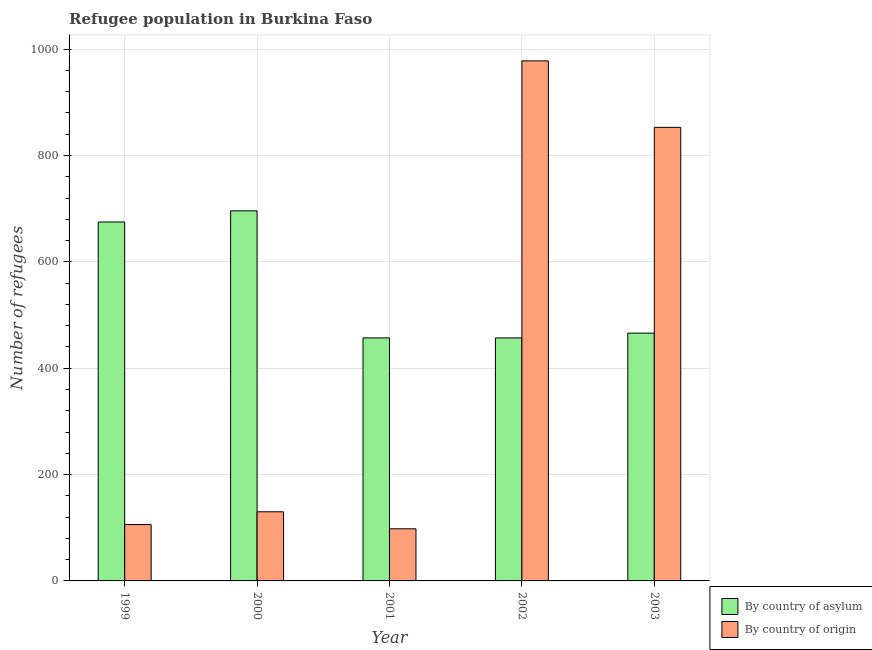How many different coloured bars are there?
Provide a short and direct response. 2. Are the number of bars per tick equal to the number of legend labels?
Offer a very short reply. Yes. How many bars are there on the 5th tick from the right?
Give a very brief answer. 2. What is the number of refugees by country of origin in 2000?
Give a very brief answer. 130. Across all years, what is the maximum number of refugees by country of asylum?
Offer a very short reply. 696. Across all years, what is the minimum number of refugees by country of asylum?
Provide a short and direct response. 457. In which year was the number of refugees by country of origin maximum?
Ensure brevity in your answer.  2002. What is the total number of refugees by country of asylum in the graph?
Your answer should be compact. 2751. What is the difference between the number of refugees by country of asylum in 2000 and that in 2002?
Your answer should be very brief. 239. What is the difference between the number of refugees by country of asylum in 2001 and the number of refugees by country of origin in 2003?
Ensure brevity in your answer.  -9. What is the average number of refugees by country of origin per year?
Your answer should be compact. 433. What is the ratio of the number of refugees by country of origin in 2002 to that in 2003?
Give a very brief answer. 1.15. Is the number of refugees by country of asylum in 2000 less than that in 2002?
Your response must be concise. No. What is the difference between the highest and the second highest number of refugees by country of origin?
Make the answer very short. 125. What is the difference between the highest and the lowest number of refugees by country of asylum?
Keep it short and to the point. 239. What does the 1st bar from the left in 2000 represents?
Your answer should be very brief. By country of asylum. What does the 2nd bar from the right in 2002 represents?
Provide a short and direct response. By country of asylum. How many bars are there?
Offer a very short reply. 10. What is the difference between two consecutive major ticks on the Y-axis?
Your answer should be compact. 200. Does the graph contain any zero values?
Ensure brevity in your answer.  No. Where does the legend appear in the graph?
Offer a very short reply. Bottom right. What is the title of the graph?
Make the answer very short. Refugee population in Burkina Faso. Does "Old" appear as one of the legend labels in the graph?
Give a very brief answer. No. What is the label or title of the X-axis?
Provide a succinct answer. Year. What is the label or title of the Y-axis?
Make the answer very short. Number of refugees. What is the Number of refugees in By country of asylum in 1999?
Give a very brief answer. 675. What is the Number of refugees of By country of origin in 1999?
Keep it short and to the point. 106. What is the Number of refugees in By country of asylum in 2000?
Provide a short and direct response. 696. What is the Number of refugees of By country of origin in 2000?
Ensure brevity in your answer.  130. What is the Number of refugees of By country of asylum in 2001?
Ensure brevity in your answer.  457. What is the Number of refugees of By country of asylum in 2002?
Offer a terse response. 457. What is the Number of refugees in By country of origin in 2002?
Your answer should be very brief. 978. What is the Number of refugees in By country of asylum in 2003?
Your response must be concise. 466. What is the Number of refugees in By country of origin in 2003?
Provide a short and direct response. 853. Across all years, what is the maximum Number of refugees in By country of asylum?
Provide a succinct answer. 696. Across all years, what is the maximum Number of refugees in By country of origin?
Offer a very short reply. 978. Across all years, what is the minimum Number of refugees in By country of asylum?
Give a very brief answer. 457. What is the total Number of refugees of By country of asylum in the graph?
Offer a very short reply. 2751. What is the total Number of refugees of By country of origin in the graph?
Offer a terse response. 2165. What is the difference between the Number of refugees in By country of asylum in 1999 and that in 2001?
Provide a succinct answer. 218. What is the difference between the Number of refugees of By country of asylum in 1999 and that in 2002?
Offer a terse response. 218. What is the difference between the Number of refugees of By country of origin in 1999 and that in 2002?
Give a very brief answer. -872. What is the difference between the Number of refugees in By country of asylum in 1999 and that in 2003?
Ensure brevity in your answer.  209. What is the difference between the Number of refugees of By country of origin in 1999 and that in 2003?
Keep it short and to the point. -747. What is the difference between the Number of refugees of By country of asylum in 2000 and that in 2001?
Ensure brevity in your answer.  239. What is the difference between the Number of refugees of By country of origin in 2000 and that in 2001?
Offer a very short reply. 32. What is the difference between the Number of refugees of By country of asylum in 2000 and that in 2002?
Ensure brevity in your answer.  239. What is the difference between the Number of refugees of By country of origin in 2000 and that in 2002?
Your answer should be very brief. -848. What is the difference between the Number of refugees in By country of asylum in 2000 and that in 2003?
Offer a terse response. 230. What is the difference between the Number of refugees in By country of origin in 2000 and that in 2003?
Give a very brief answer. -723. What is the difference between the Number of refugees of By country of origin in 2001 and that in 2002?
Your response must be concise. -880. What is the difference between the Number of refugees in By country of origin in 2001 and that in 2003?
Provide a succinct answer. -755. What is the difference between the Number of refugees in By country of asylum in 2002 and that in 2003?
Keep it short and to the point. -9. What is the difference between the Number of refugees in By country of origin in 2002 and that in 2003?
Offer a terse response. 125. What is the difference between the Number of refugees in By country of asylum in 1999 and the Number of refugees in By country of origin in 2000?
Your answer should be very brief. 545. What is the difference between the Number of refugees in By country of asylum in 1999 and the Number of refugees in By country of origin in 2001?
Offer a terse response. 577. What is the difference between the Number of refugees of By country of asylum in 1999 and the Number of refugees of By country of origin in 2002?
Make the answer very short. -303. What is the difference between the Number of refugees of By country of asylum in 1999 and the Number of refugees of By country of origin in 2003?
Your answer should be very brief. -178. What is the difference between the Number of refugees of By country of asylum in 2000 and the Number of refugees of By country of origin in 2001?
Keep it short and to the point. 598. What is the difference between the Number of refugees in By country of asylum in 2000 and the Number of refugees in By country of origin in 2002?
Your answer should be compact. -282. What is the difference between the Number of refugees of By country of asylum in 2000 and the Number of refugees of By country of origin in 2003?
Keep it short and to the point. -157. What is the difference between the Number of refugees in By country of asylum in 2001 and the Number of refugees in By country of origin in 2002?
Keep it short and to the point. -521. What is the difference between the Number of refugees of By country of asylum in 2001 and the Number of refugees of By country of origin in 2003?
Your response must be concise. -396. What is the difference between the Number of refugees of By country of asylum in 2002 and the Number of refugees of By country of origin in 2003?
Make the answer very short. -396. What is the average Number of refugees in By country of asylum per year?
Ensure brevity in your answer.  550.2. What is the average Number of refugees in By country of origin per year?
Your answer should be very brief. 433. In the year 1999, what is the difference between the Number of refugees of By country of asylum and Number of refugees of By country of origin?
Your answer should be very brief. 569. In the year 2000, what is the difference between the Number of refugees in By country of asylum and Number of refugees in By country of origin?
Your answer should be very brief. 566. In the year 2001, what is the difference between the Number of refugees in By country of asylum and Number of refugees in By country of origin?
Offer a terse response. 359. In the year 2002, what is the difference between the Number of refugees of By country of asylum and Number of refugees of By country of origin?
Give a very brief answer. -521. In the year 2003, what is the difference between the Number of refugees of By country of asylum and Number of refugees of By country of origin?
Your answer should be very brief. -387. What is the ratio of the Number of refugees in By country of asylum in 1999 to that in 2000?
Keep it short and to the point. 0.97. What is the ratio of the Number of refugees of By country of origin in 1999 to that in 2000?
Make the answer very short. 0.82. What is the ratio of the Number of refugees of By country of asylum in 1999 to that in 2001?
Your response must be concise. 1.48. What is the ratio of the Number of refugees of By country of origin in 1999 to that in 2001?
Provide a succinct answer. 1.08. What is the ratio of the Number of refugees in By country of asylum in 1999 to that in 2002?
Your answer should be compact. 1.48. What is the ratio of the Number of refugees in By country of origin in 1999 to that in 2002?
Provide a succinct answer. 0.11. What is the ratio of the Number of refugees of By country of asylum in 1999 to that in 2003?
Offer a very short reply. 1.45. What is the ratio of the Number of refugees of By country of origin in 1999 to that in 2003?
Offer a terse response. 0.12. What is the ratio of the Number of refugees in By country of asylum in 2000 to that in 2001?
Provide a short and direct response. 1.52. What is the ratio of the Number of refugees in By country of origin in 2000 to that in 2001?
Your answer should be very brief. 1.33. What is the ratio of the Number of refugees in By country of asylum in 2000 to that in 2002?
Your answer should be very brief. 1.52. What is the ratio of the Number of refugees in By country of origin in 2000 to that in 2002?
Your answer should be compact. 0.13. What is the ratio of the Number of refugees in By country of asylum in 2000 to that in 2003?
Your answer should be very brief. 1.49. What is the ratio of the Number of refugees in By country of origin in 2000 to that in 2003?
Keep it short and to the point. 0.15. What is the ratio of the Number of refugees of By country of origin in 2001 to that in 2002?
Your response must be concise. 0.1. What is the ratio of the Number of refugees of By country of asylum in 2001 to that in 2003?
Your answer should be very brief. 0.98. What is the ratio of the Number of refugees of By country of origin in 2001 to that in 2003?
Offer a very short reply. 0.11. What is the ratio of the Number of refugees in By country of asylum in 2002 to that in 2003?
Provide a short and direct response. 0.98. What is the ratio of the Number of refugees of By country of origin in 2002 to that in 2003?
Offer a terse response. 1.15. What is the difference between the highest and the second highest Number of refugees of By country of origin?
Make the answer very short. 125. What is the difference between the highest and the lowest Number of refugees of By country of asylum?
Give a very brief answer. 239. What is the difference between the highest and the lowest Number of refugees of By country of origin?
Offer a terse response. 880. 